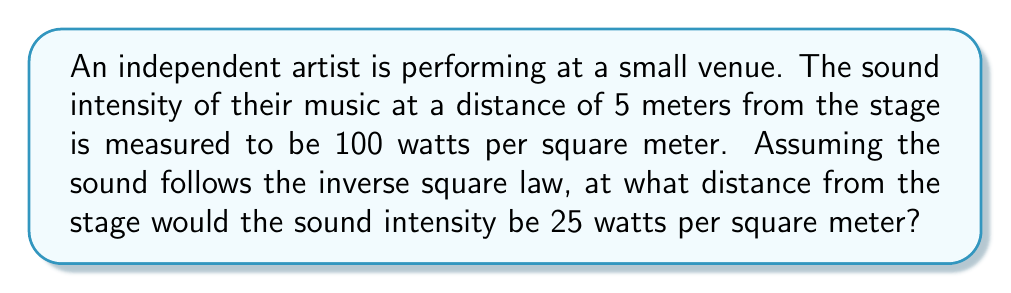Provide a solution to this math problem. Let's approach this step-by-step using the inverse square law for sound intensity:

1) The inverse square law for sound intensity is given by:

   $$I = \frac{k}{r^2}$$

   where $I$ is the sound intensity, $k$ is a constant, and $r$ is the distance from the source.

2) We know two points:
   At $r_1 = 5$ meters, $I_1 = 100$ watts/m²
   We need to find $r_2$ where $I_2 = 25$ watts/m²

3) Let's find the constant $k$ using the first point:

   $$100 = \frac{k}{5^2}$$
   $$k = 100 * 25 = 2500$$

4) Now we can set up an equation for the second point:

   $$25 = \frac{2500}{r_2^2}$$

5) Solve for $r_2$:

   $$r_2^2 = \frac{2500}{25} = 100$$
   $$r_2 = \sqrt{100} = 10$$

Therefore, the sound intensity would be 25 watts/m² at a distance of 10 meters from the stage.
Answer: 10 meters 